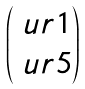<formula> <loc_0><loc_0><loc_500><loc_500>\begin{pmatrix} \ u r { 1 } \\ \ u r { 5 } \\ \end{pmatrix}</formula> 